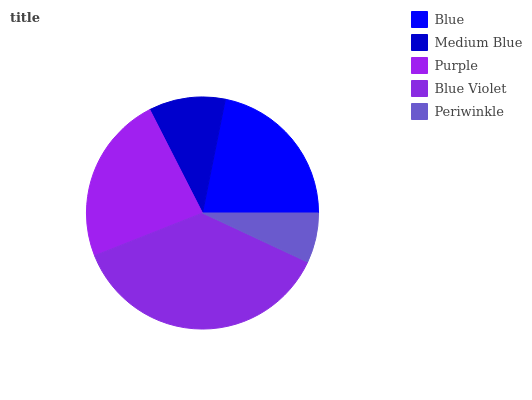Is Periwinkle the minimum?
Answer yes or no. Yes. Is Blue Violet the maximum?
Answer yes or no. Yes. Is Medium Blue the minimum?
Answer yes or no. No. Is Medium Blue the maximum?
Answer yes or no. No. Is Blue greater than Medium Blue?
Answer yes or no. Yes. Is Medium Blue less than Blue?
Answer yes or no. Yes. Is Medium Blue greater than Blue?
Answer yes or no. No. Is Blue less than Medium Blue?
Answer yes or no. No. Is Blue the high median?
Answer yes or no. Yes. Is Blue the low median?
Answer yes or no. Yes. Is Periwinkle the high median?
Answer yes or no. No. Is Blue Violet the low median?
Answer yes or no. No. 